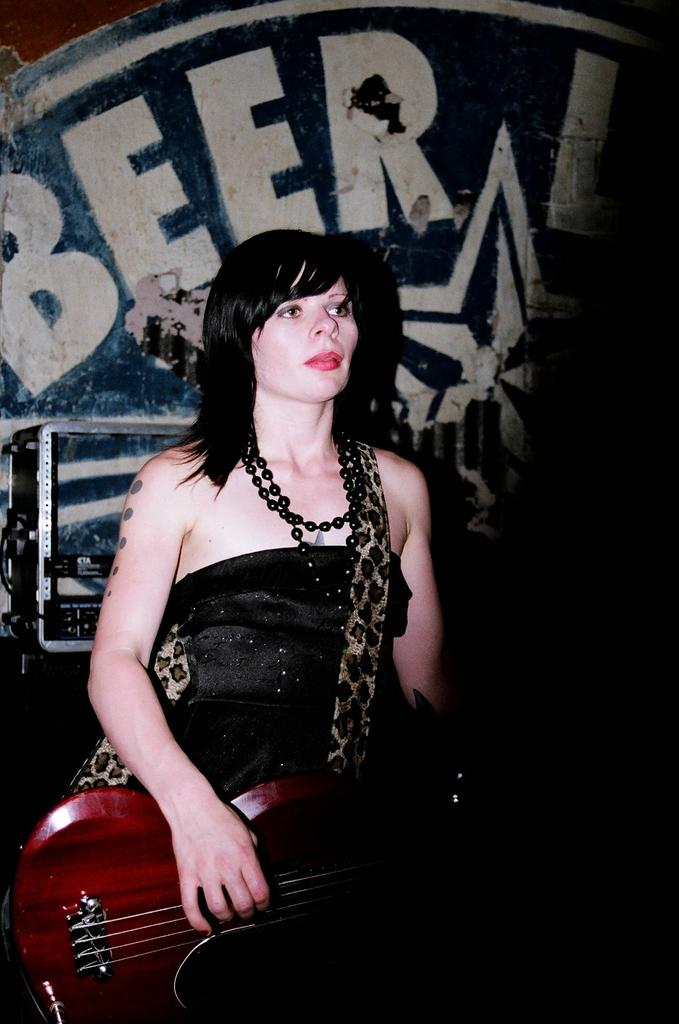Who is the main subject in the image? There is a woman in the image. What is the woman doing in the image? The woman is playing a guitar. What type of shirt is the governor wearing in the image? There is no governor or shirt present in the image; it only features a woman playing a guitar. 